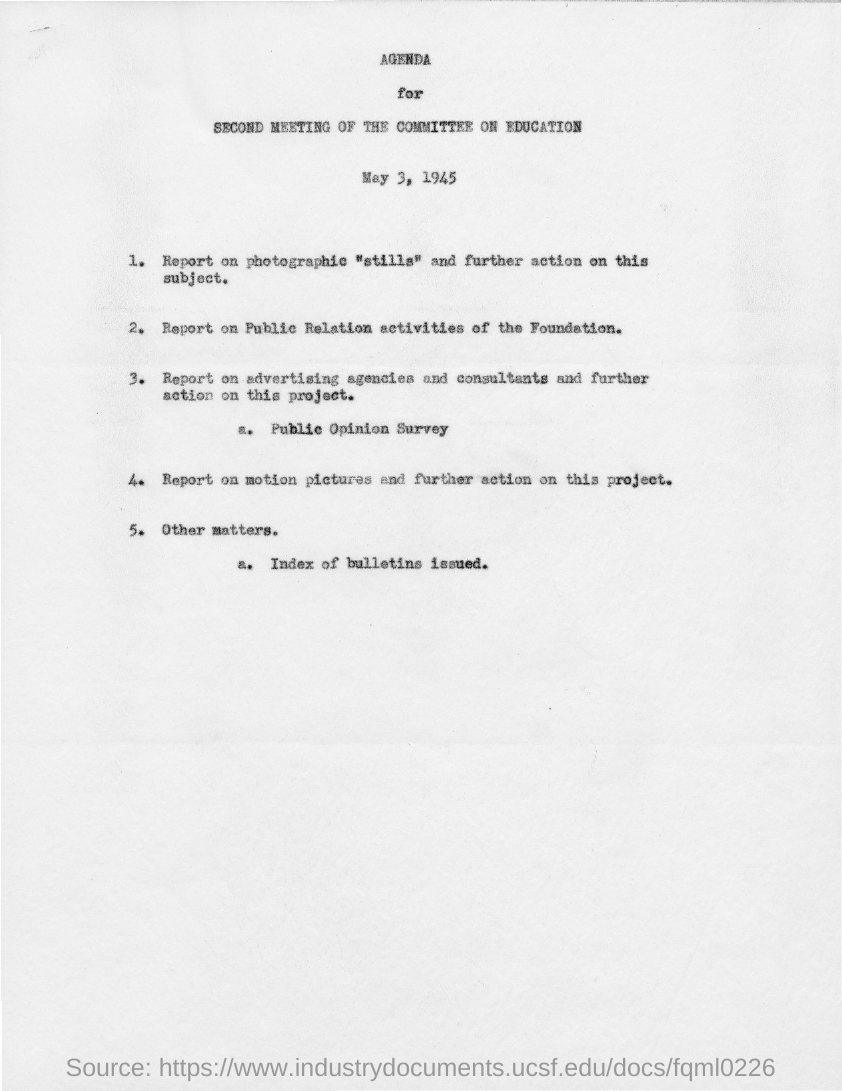Identify some key points in this picture. The second meeting of the committee on education took place on May 3, 1945. 